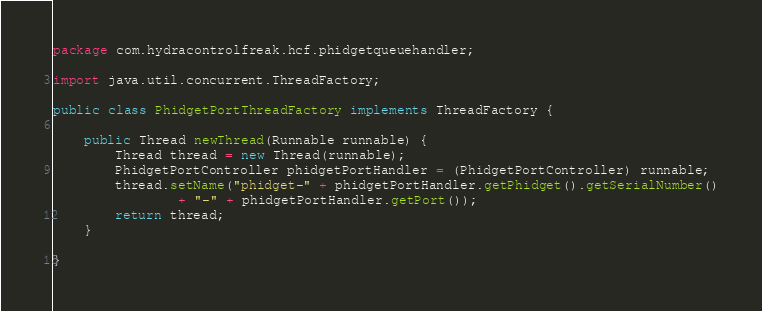Convert code to text. <code><loc_0><loc_0><loc_500><loc_500><_Java_>package com.hydracontrolfreak.hcf.phidgetqueuehandler;

import java.util.concurrent.ThreadFactory;

public class PhidgetPortThreadFactory implements ThreadFactory {
	
	public Thread newThread(Runnable runnable) {
		Thread thread = new Thread(runnable);
		PhidgetPortController phidgetPortHandler = (PhidgetPortController) runnable;
		thread.setName("phidget-" + phidgetPortHandler.getPhidget().getSerialNumber()
				+ "-" + phidgetPortHandler.getPort());
		return thread;
	}

}
</code> 